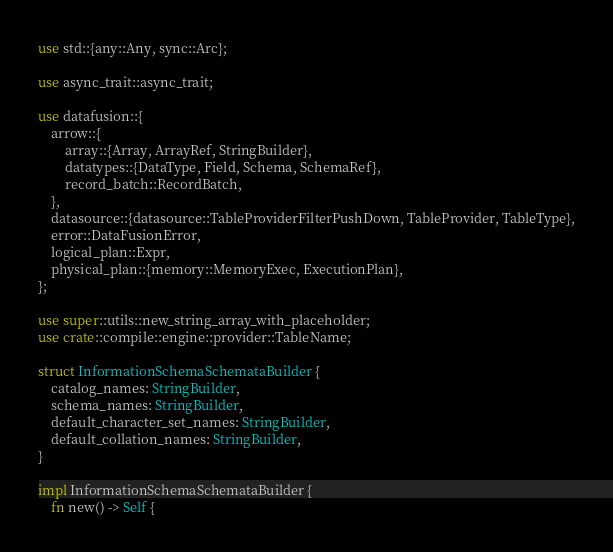<code> <loc_0><loc_0><loc_500><loc_500><_Rust_>use std::{any::Any, sync::Arc};

use async_trait::async_trait;

use datafusion::{
    arrow::{
        array::{Array, ArrayRef, StringBuilder},
        datatypes::{DataType, Field, Schema, SchemaRef},
        record_batch::RecordBatch,
    },
    datasource::{datasource::TableProviderFilterPushDown, TableProvider, TableType},
    error::DataFusionError,
    logical_plan::Expr,
    physical_plan::{memory::MemoryExec, ExecutionPlan},
};

use super::utils::new_string_array_with_placeholder;
use crate::compile::engine::provider::TableName;

struct InformationSchemaSchemataBuilder {
    catalog_names: StringBuilder,
    schema_names: StringBuilder,
    default_character_set_names: StringBuilder,
    default_collation_names: StringBuilder,
}

impl InformationSchemaSchemataBuilder {
    fn new() -> Self {</code> 